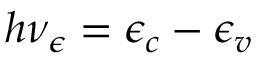Convert formula to latex. <formula><loc_0><loc_0><loc_500><loc_500>h \nu _ { \epsilon } = \epsilon _ { c } - \epsilon _ { v }</formula> 